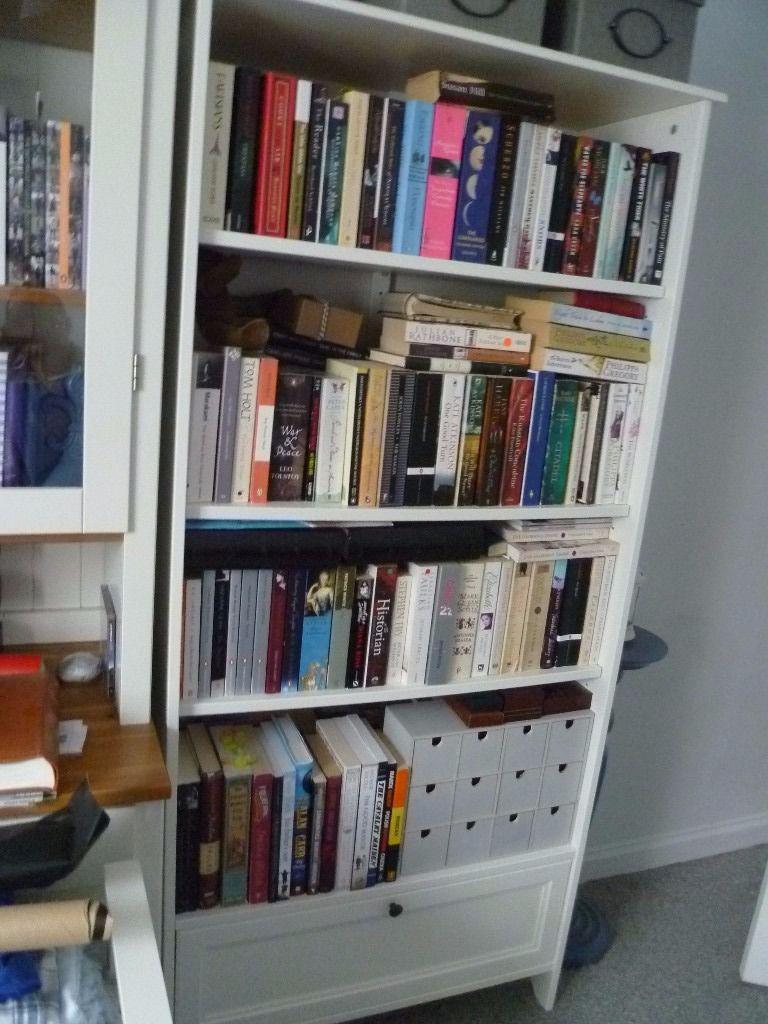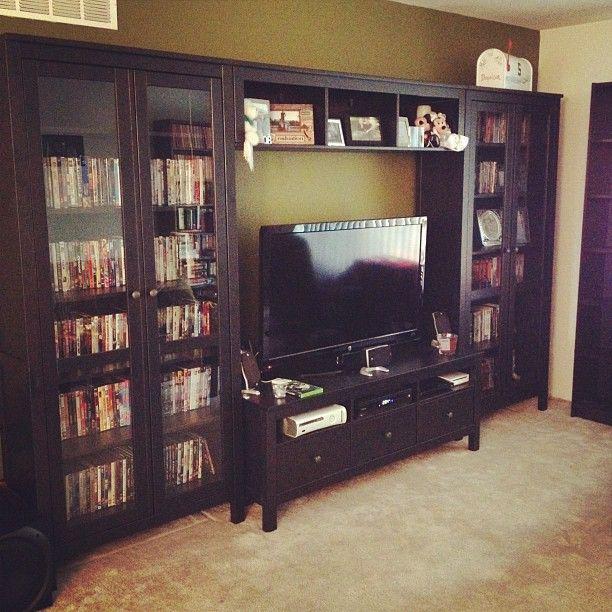The first image is the image on the left, the second image is the image on the right. Assess this claim about the two images: "One image features a traditional desk up against a wall, with a hutch on top of the desk, a one-door cabinet underneath on the left, and two drawers on the right.". Correct or not? Answer yes or no. No. The first image is the image on the left, the second image is the image on the right. Given the left and right images, does the statement "There is a desk in each image." hold true? Answer yes or no. No. 